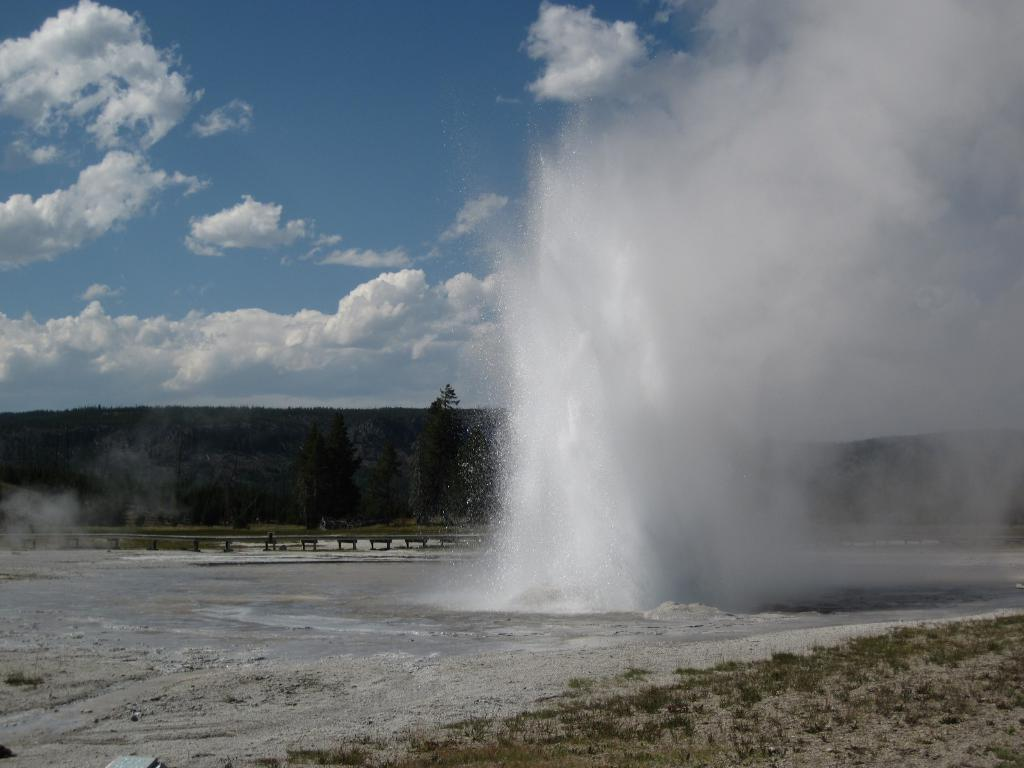What type of terrain is visible at the bottom of the image? There is grass and water at the bottom of the image. What can be seen at the top of the image? There are trees and hills at the top of the image. What is visible in the sky in the image? There are clouds in the sky, and the sky is visible at the top of the image. Are there any giants attending the event depicted in the image? There is no event or giants present in the image; it features a landscape with grass, water, trees, hills, clouds, and sky. What type of bread can be seen in the image? There is no bread present in the image. 